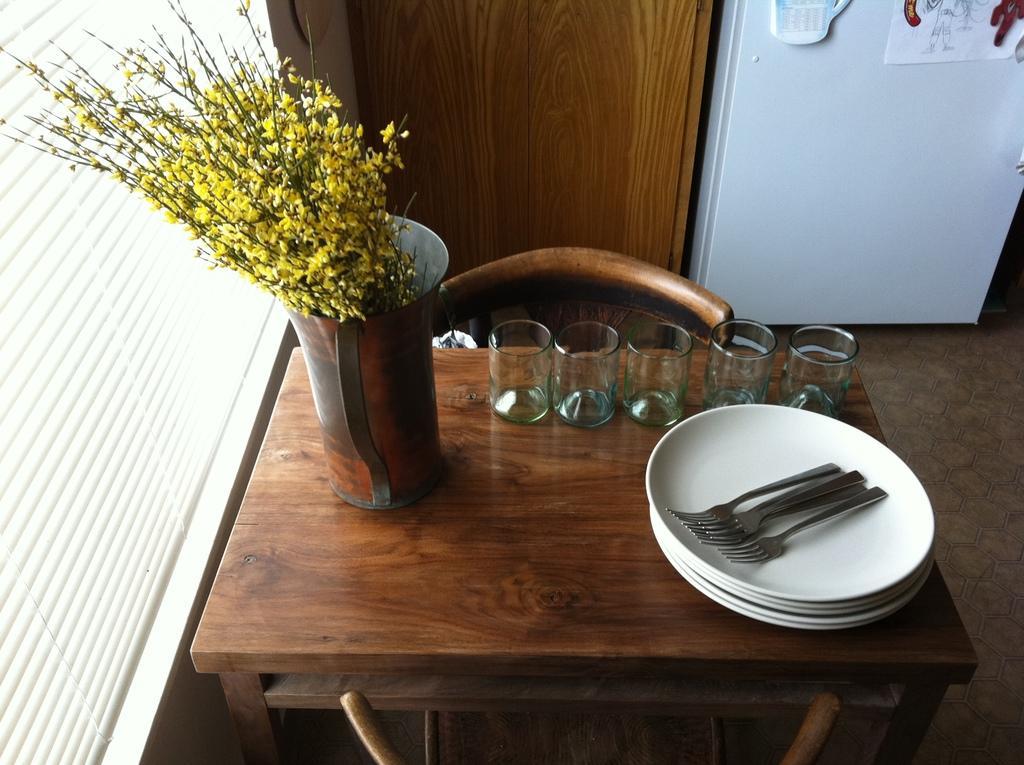Describe this image in one or two sentences. In this picture we can see a table, on which we can see some glasses, plates, spoons and we can see flower vase. 